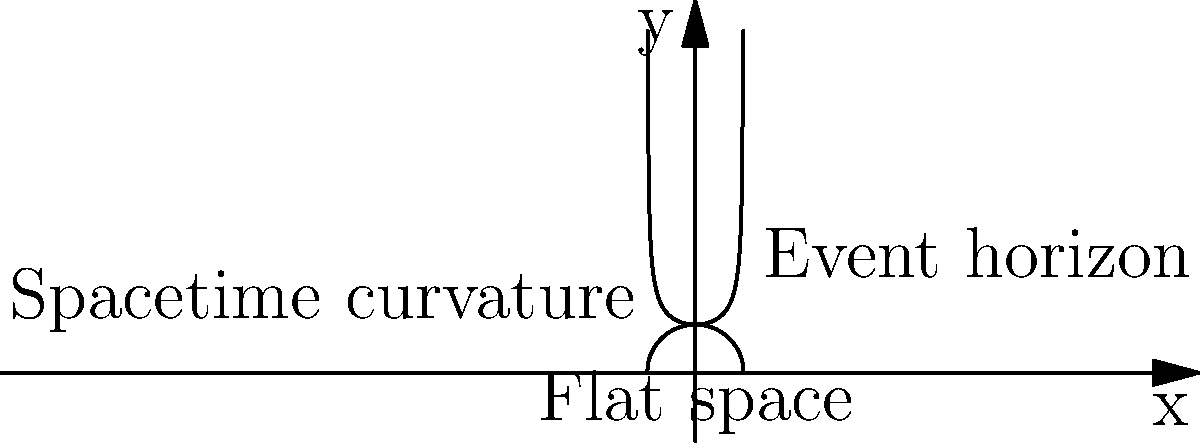As a confident and adventurous Pikachu exploring the depths of space, you encounter a black hole. Near its event horizon, you notice that the curvature of spacetime becomes extreme. If the curvature of spacetime is represented by the function $f(x) = \frac{1}{\sqrt{1-x^2}}$ where $x$ is the distance from the center of the black hole (with $x=1$ being the event horizon), what is the limit of the curvature as you approach the event horizon? Let's approach this step-by-step:

1) The function representing the curvature of spacetime is given as:

   $$f(x) = \frac{1}{\sqrt{1-x^2}}$$

2) We want to find the limit of this function as x approaches 1 (the event horizon).

3) We can write this limit as:

   $$\lim_{x \to 1} \frac{1}{\sqrt{1-x^2}}$$

4) As x gets closer to 1, the denominator $\sqrt{1-x^2}$ gets closer to 0.

5) When a positive number in the denominator approaches 0, the fraction as a whole grows without bound.

6) In mathematical terms, we say that the limit "approaches infinity" as x approaches 1.

7) This is often written as:

   $$\lim_{x \to 1} \frac{1}{\sqrt{1-x^2}} = \infty$$

8) This result aligns with our understanding of black holes: at the event horizon, the curvature of spacetime becomes infinite, which is why nothing can escape once it crosses this boundary.
Answer: $\infty$ 